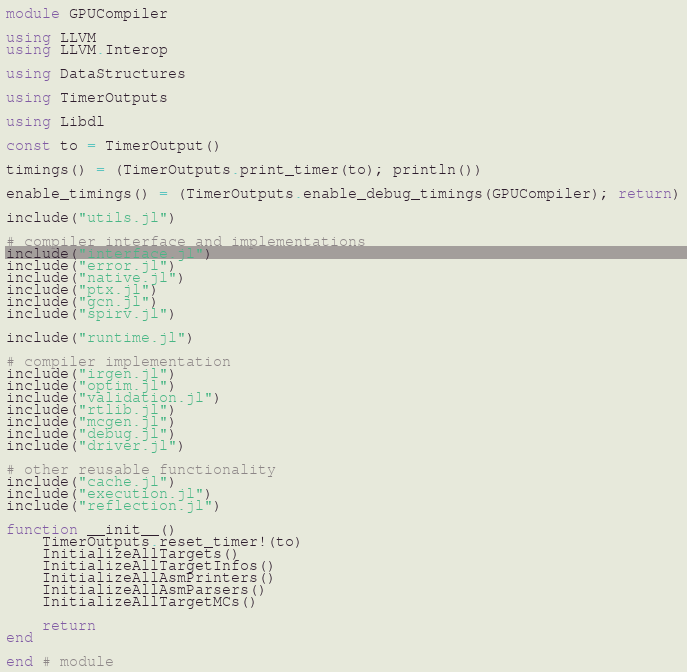Convert code to text. <code><loc_0><loc_0><loc_500><loc_500><_Julia_>module GPUCompiler

using LLVM
using LLVM.Interop

using DataStructures

using TimerOutputs

using Libdl

const to = TimerOutput()

timings() = (TimerOutputs.print_timer(to); println())

enable_timings() = (TimerOutputs.enable_debug_timings(GPUCompiler); return)

include("utils.jl")

# compiler interface and implementations
include("interface.jl")
include("error.jl")
include("native.jl")
include("ptx.jl")
include("gcn.jl")
include("spirv.jl")

include("runtime.jl")

# compiler implementation
include("irgen.jl")
include("optim.jl")
include("validation.jl")
include("rtlib.jl")
include("mcgen.jl")
include("debug.jl")
include("driver.jl")

# other reusable functionality
include("cache.jl")
include("execution.jl")
include("reflection.jl")

function __init__()
    TimerOutputs.reset_timer!(to)
    InitializeAllTargets()
    InitializeAllTargetInfos()
    InitializeAllAsmPrinters()
    InitializeAllAsmParsers()
    InitializeAllTargetMCs()

    return
end

end # module
</code> 